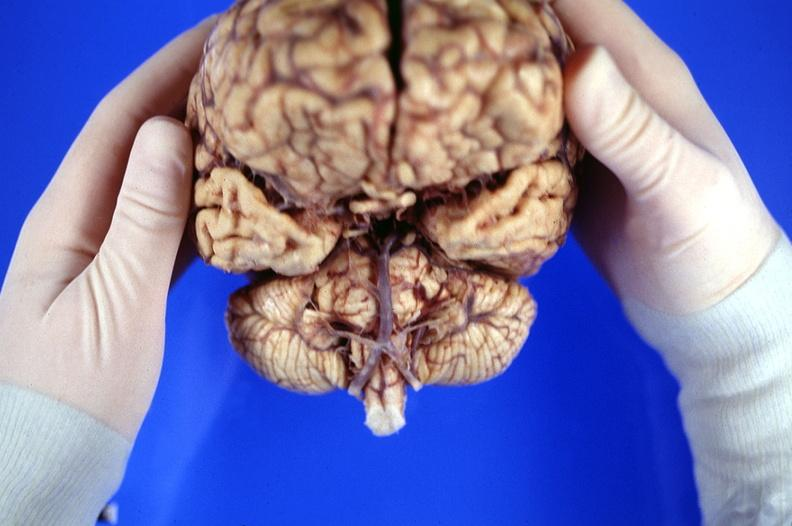s nervous present?
Answer the question using a single word or phrase. Yes 